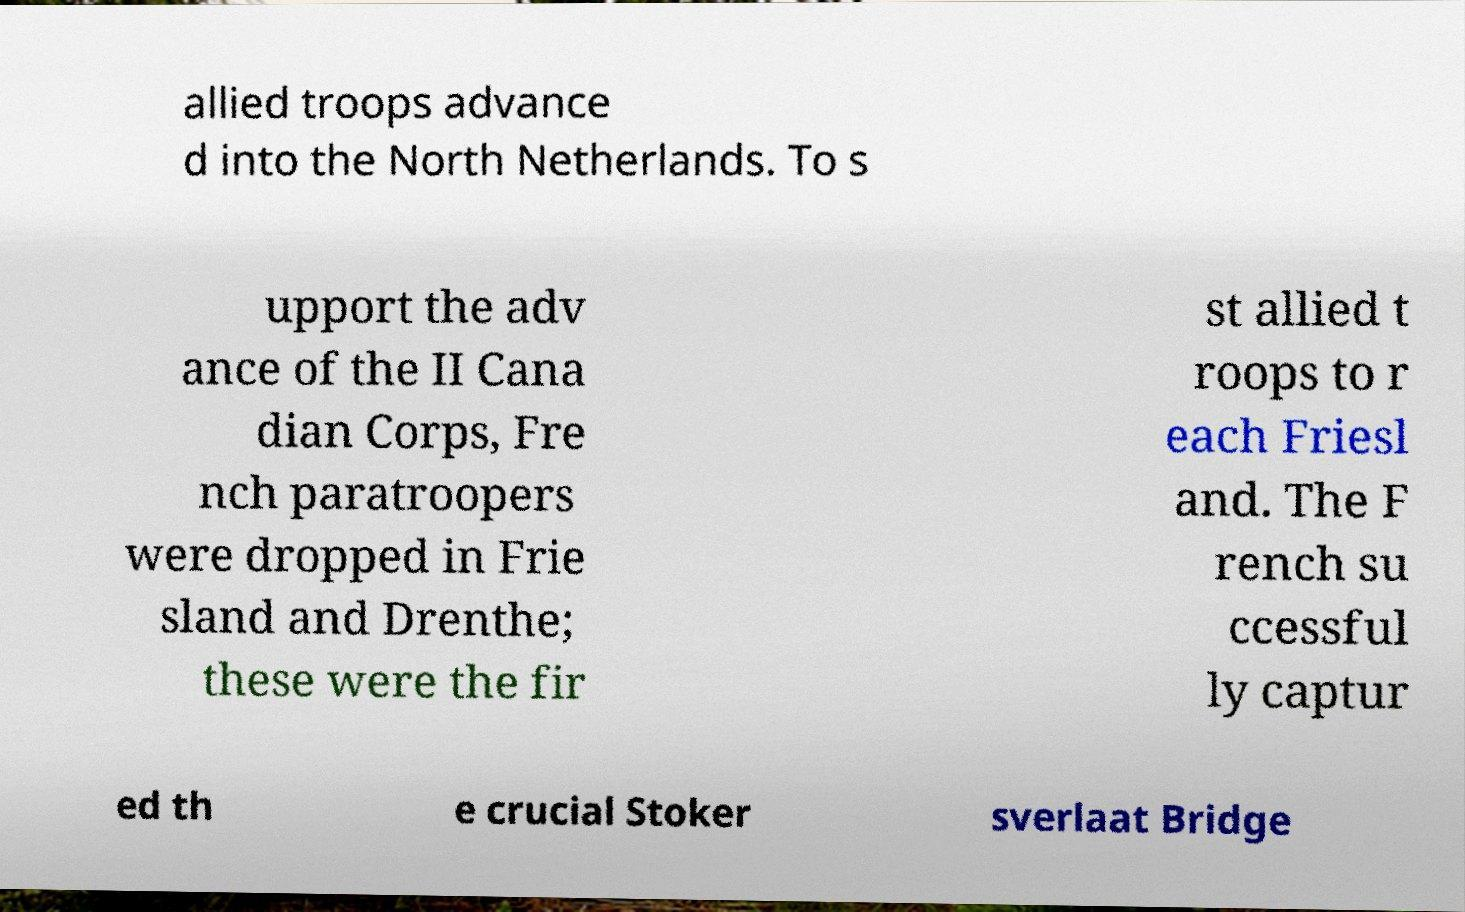Could you extract and type out the text from this image? allied troops advance d into the North Netherlands. To s upport the adv ance of the II Cana dian Corps, Fre nch paratroopers were dropped in Frie sland and Drenthe; these were the fir st allied t roops to r each Friesl and. The F rench su ccessful ly captur ed th e crucial Stoker sverlaat Bridge 